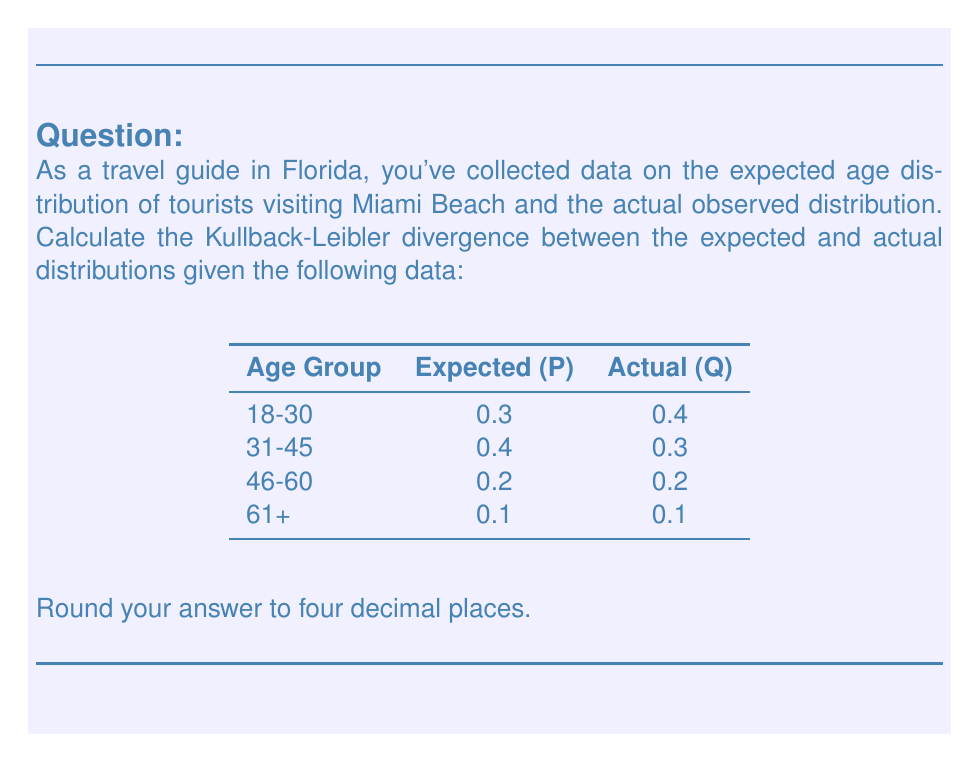Could you help me with this problem? To calculate the Kullback-Leibler divergence between the expected distribution P and the actual distribution Q, we use the formula:

$$ D_{KL}(P||Q) = \sum_{i} P(i) \log\left(\frac{P(i)}{Q(i)}\right) $$

Where $P(i)$ is the probability of the i-th event in distribution P, and $Q(i)$ is the probability of the i-th event in distribution Q.

Let's calculate this step-by-step:

1) For the 18-30 age group:
   $P(1) = 0.3$, $Q(1) = 0.4$
   $0.3 \log\left(\frac{0.3}{0.4}\right) = 0.3 \log(0.75) = -0.0863$

2) For the 31-45 age group:
   $P(2) = 0.4$, $Q(2) = 0.3$
   $0.4 \log\left(\frac{0.4}{0.3}\right) = 0.4 \log(1.3333) = 0.1151$

3) For the 46-60 age group:
   $P(3) = 0.2$, $Q(3) = 0.2$
   $0.2 \log\left(\frac{0.2}{0.2}\right) = 0.2 \log(1) = 0$

4) For the 61+ age group:
   $P(4) = 0.1$, $Q(4) = 0.1$
   $0.1 \log\left(\frac{0.1}{0.1}\right) = 0.1 \log(1) = 0$

Now, we sum all these values:

$$ D_{KL}(P||Q) = (-0.0863) + 0.1151 + 0 + 0 = 0.0288 $$

Rounding to four decimal places gives us 0.0288.
Answer: 0.0288 